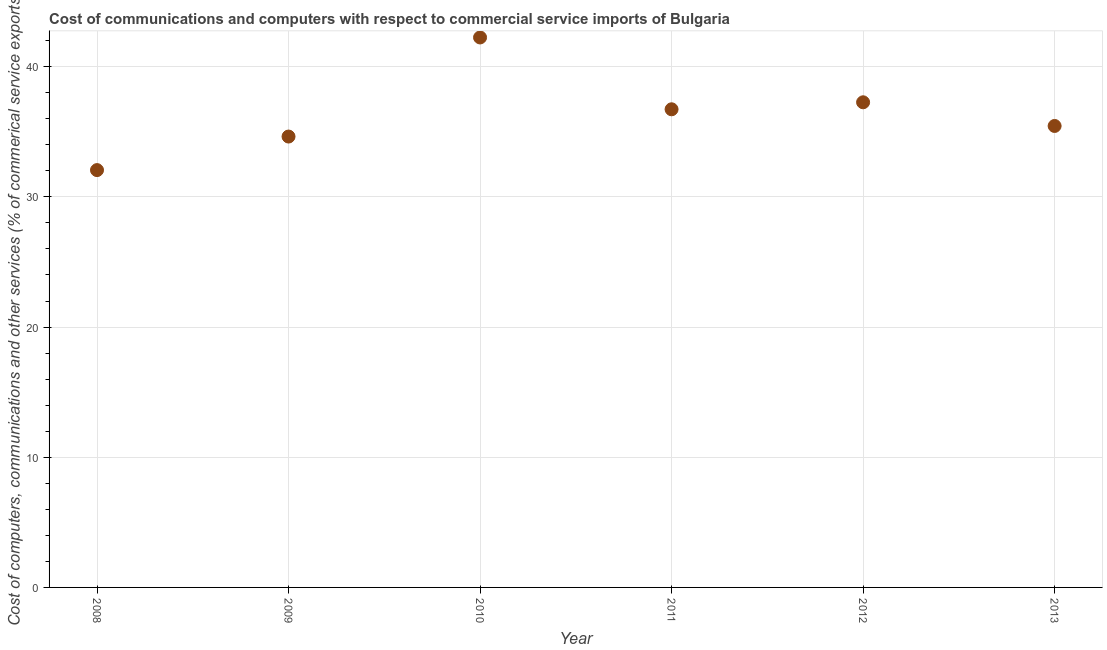What is the  computer and other services in 2008?
Keep it short and to the point. 32.06. Across all years, what is the maximum cost of communications?
Keep it short and to the point. 42.25. Across all years, what is the minimum  computer and other services?
Offer a terse response. 32.06. What is the sum of the  computer and other services?
Offer a very short reply. 218.38. What is the difference between the  computer and other services in 2008 and 2009?
Offer a terse response. -2.58. What is the average cost of communications per year?
Offer a terse response. 36.4. What is the median cost of communications?
Ensure brevity in your answer.  36.09. In how many years, is the  computer and other services greater than 24 %?
Offer a very short reply. 6. Do a majority of the years between 2009 and 2012 (inclusive) have  computer and other services greater than 24 %?
Your answer should be very brief. Yes. What is the ratio of the cost of communications in 2009 to that in 2012?
Offer a terse response. 0.93. Is the  computer and other services in 2008 less than that in 2011?
Keep it short and to the point. Yes. Is the difference between the cost of communications in 2011 and 2012 greater than the difference between any two years?
Your response must be concise. No. What is the difference between the highest and the second highest  computer and other services?
Provide a short and direct response. 4.98. What is the difference between the highest and the lowest  computer and other services?
Keep it short and to the point. 10.19. In how many years, is the cost of communications greater than the average cost of communications taken over all years?
Offer a very short reply. 3. How many dotlines are there?
Offer a terse response. 1. How many years are there in the graph?
Keep it short and to the point. 6. Does the graph contain any zero values?
Offer a terse response. No. Does the graph contain grids?
Your answer should be very brief. Yes. What is the title of the graph?
Your answer should be compact. Cost of communications and computers with respect to commercial service imports of Bulgaria. What is the label or title of the Y-axis?
Keep it short and to the point. Cost of computers, communications and other services (% of commerical service exports). What is the Cost of computers, communications and other services (% of commerical service exports) in 2008?
Give a very brief answer. 32.06. What is the Cost of computers, communications and other services (% of commerical service exports) in 2009?
Your answer should be very brief. 34.63. What is the Cost of computers, communications and other services (% of commerical service exports) in 2010?
Your answer should be very brief. 42.25. What is the Cost of computers, communications and other services (% of commerical service exports) in 2011?
Your answer should be compact. 36.73. What is the Cost of computers, communications and other services (% of commerical service exports) in 2012?
Provide a succinct answer. 37.27. What is the Cost of computers, communications and other services (% of commerical service exports) in 2013?
Ensure brevity in your answer.  35.45. What is the difference between the Cost of computers, communications and other services (% of commerical service exports) in 2008 and 2009?
Offer a terse response. -2.58. What is the difference between the Cost of computers, communications and other services (% of commerical service exports) in 2008 and 2010?
Your answer should be very brief. -10.19. What is the difference between the Cost of computers, communications and other services (% of commerical service exports) in 2008 and 2011?
Provide a succinct answer. -4.67. What is the difference between the Cost of computers, communications and other services (% of commerical service exports) in 2008 and 2012?
Keep it short and to the point. -5.21. What is the difference between the Cost of computers, communications and other services (% of commerical service exports) in 2008 and 2013?
Keep it short and to the point. -3.39. What is the difference between the Cost of computers, communications and other services (% of commerical service exports) in 2009 and 2010?
Make the answer very short. -7.61. What is the difference between the Cost of computers, communications and other services (% of commerical service exports) in 2009 and 2011?
Offer a terse response. -2.09. What is the difference between the Cost of computers, communications and other services (% of commerical service exports) in 2009 and 2012?
Ensure brevity in your answer.  -2.63. What is the difference between the Cost of computers, communications and other services (% of commerical service exports) in 2009 and 2013?
Give a very brief answer. -0.81. What is the difference between the Cost of computers, communications and other services (% of commerical service exports) in 2010 and 2011?
Give a very brief answer. 5.52. What is the difference between the Cost of computers, communications and other services (% of commerical service exports) in 2010 and 2012?
Make the answer very short. 4.98. What is the difference between the Cost of computers, communications and other services (% of commerical service exports) in 2010 and 2013?
Make the answer very short. 6.8. What is the difference between the Cost of computers, communications and other services (% of commerical service exports) in 2011 and 2012?
Provide a succinct answer. -0.54. What is the difference between the Cost of computers, communications and other services (% of commerical service exports) in 2011 and 2013?
Keep it short and to the point. 1.28. What is the difference between the Cost of computers, communications and other services (% of commerical service exports) in 2012 and 2013?
Your answer should be compact. 1.82. What is the ratio of the Cost of computers, communications and other services (% of commerical service exports) in 2008 to that in 2009?
Your answer should be very brief. 0.93. What is the ratio of the Cost of computers, communications and other services (% of commerical service exports) in 2008 to that in 2010?
Your response must be concise. 0.76. What is the ratio of the Cost of computers, communications and other services (% of commerical service exports) in 2008 to that in 2011?
Give a very brief answer. 0.87. What is the ratio of the Cost of computers, communications and other services (% of commerical service exports) in 2008 to that in 2012?
Your response must be concise. 0.86. What is the ratio of the Cost of computers, communications and other services (% of commerical service exports) in 2008 to that in 2013?
Ensure brevity in your answer.  0.9. What is the ratio of the Cost of computers, communications and other services (% of commerical service exports) in 2009 to that in 2010?
Offer a terse response. 0.82. What is the ratio of the Cost of computers, communications and other services (% of commerical service exports) in 2009 to that in 2011?
Give a very brief answer. 0.94. What is the ratio of the Cost of computers, communications and other services (% of commerical service exports) in 2009 to that in 2012?
Offer a very short reply. 0.93. What is the ratio of the Cost of computers, communications and other services (% of commerical service exports) in 2010 to that in 2011?
Make the answer very short. 1.15. What is the ratio of the Cost of computers, communications and other services (% of commerical service exports) in 2010 to that in 2012?
Make the answer very short. 1.13. What is the ratio of the Cost of computers, communications and other services (% of commerical service exports) in 2010 to that in 2013?
Offer a very short reply. 1.19. What is the ratio of the Cost of computers, communications and other services (% of commerical service exports) in 2011 to that in 2013?
Your answer should be compact. 1.04. What is the ratio of the Cost of computers, communications and other services (% of commerical service exports) in 2012 to that in 2013?
Ensure brevity in your answer.  1.05. 